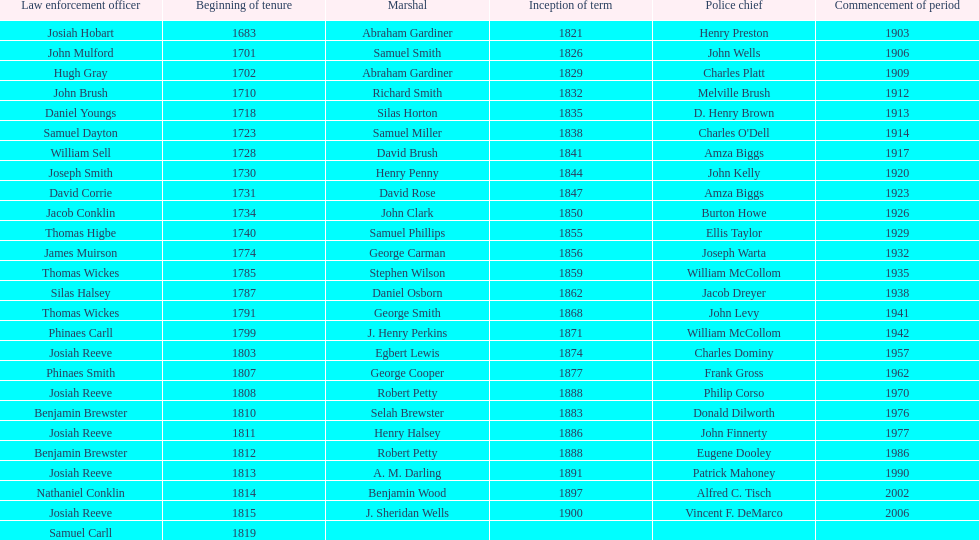When did the first sheriff's term start? 1683. 